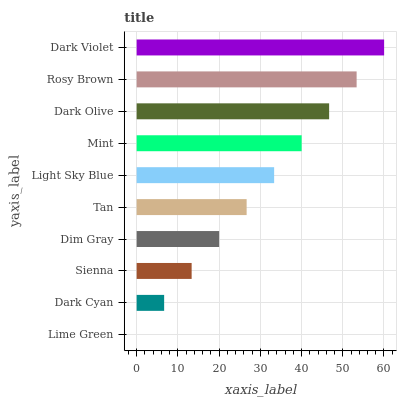Is Lime Green the minimum?
Answer yes or no. Yes. Is Dark Violet the maximum?
Answer yes or no. Yes. Is Dark Cyan the minimum?
Answer yes or no. No. Is Dark Cyan the maximum?
Answer yes or no. No. Is Dark Cyan greater than Lime Green?
Answer yes or no. Yes. Is Lime Green less than Dark Cyan?
Answer yes or no. Yes. Is Lime Green greater than Dark Cyan?
Answer yes or no. No. Is Dark Cyan less than Lime Green?
Answer yes or no. No. Is Light Sky Blue the high median?
Answer yes or no. Yes. Is Tan the low median?
Answer yes or no. Yes. Is Sienna the high median?
Answer yes or no. No. Is Dark Olive the low median?
Answer yes or no. No. 